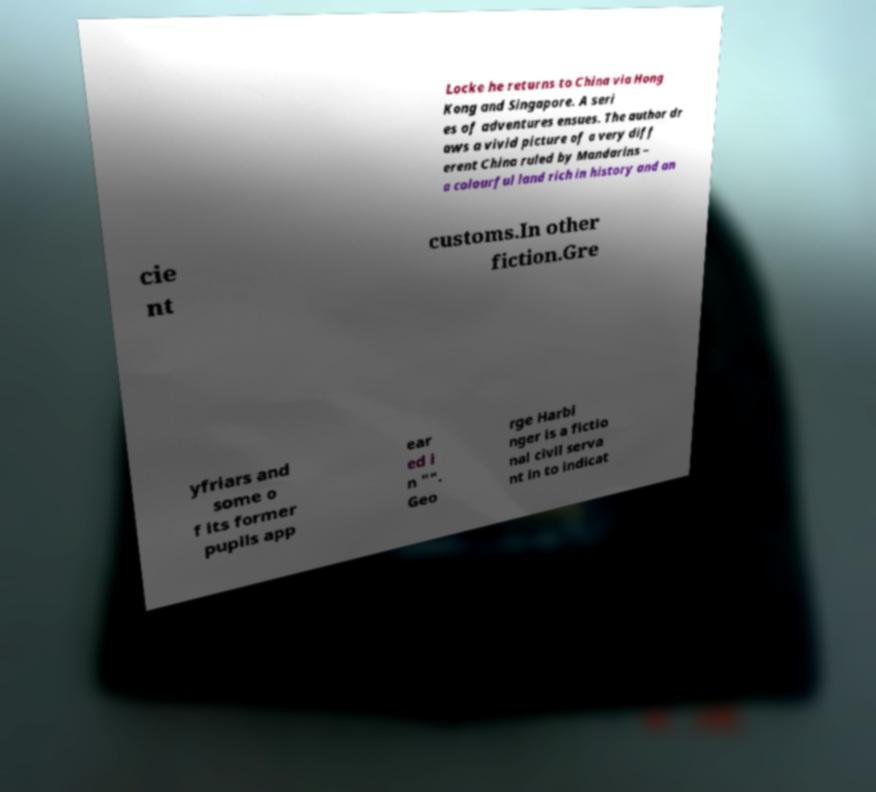Could you assist in decoding the text presented in this image and type it out clearly? Locke he returns to China via Hong Kong and Singapore. A seri es of adventures ensues. The author dr aws a vivid picture of a very diff erent China ruled by Mandarins – a colourful land rich in history and an cie nt customs.In other fiction.Gre yfriars and some o f its former pupils app ear ed i n "". Geo rge Harbi nger is a fictio nal civil serva nt in to indicat 